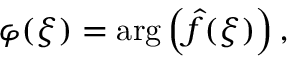<formula> <loc_0><loc_0><loc_500><loc_500>\varphi ( \xi ) = \arg \left ( { \hat { f } } ( \xi ) \right ) ,</formula> 